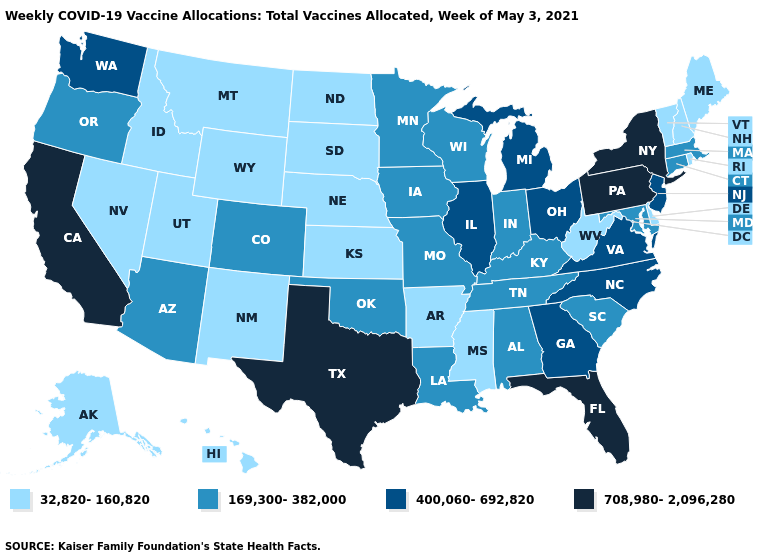Name the states that have a value in the range 169,300-382,000?
Write a very short answer. Alabama, Arizona, Colorado, Connecticut, Indiana, Iowa, Kentucky, Louisiana, Maryland, Massachusetts, Minnesota, Missouri, Oklahoma, Oregon, South Carolina, Tennessee, Wisconsin. Does South Dakota have the same value as Florida?
Quick response, please. No. Does Maryland have a lower value than Pennsylvania?
Be succinct. Yes. What is the value of Georgia?
Be succinct. 400,060-692,820. Does Washington have a lower value than California?
Give a very brief answer. Yes. Name the states that have a value in the range 169,300-382,000?
Give a very brief answer. Alabama, Arizona, Colorado, Connecticut, Indiana, Iowa, Kentucky, Louisiana, Maryland, Massachusetts, Minnesota, Missouri, Oklahoma, Oregon, South Carolina, Tennessee, Wisconsin. Name the states that have a value in the range 400,060-692,820?
Answer briefly. Georgia, Illinois, Michigan, New Jersey, North Carolina, Ohio, Virginia, Washington. What is the value of Indiana?
Short answer required. 169,300-382,000. How many symbols are there in the legend?
Be succinct. 4. Does Ohio have the highest value in the USA?
Write a very short answer. No. Name the states that have a value in the range 708,980-2,096,280?
Short answer required. California, Florida, New York, Pennsylvania, Texas. Name the states that have a value in the range 708,980-2,096,280?
Write a very short answer. California, Florida, New York, Pennsylvania, Texas. Does Pennsylvania have the highest value in the Northeast?
Short answer required. Yes. What is the value of Delaware?
Answer briefly. 32,820-160,820. Which states have the lowest value in the MidWest?
Keep it brief. Kansas, Nebraska, North Dakota, South Dakota. 